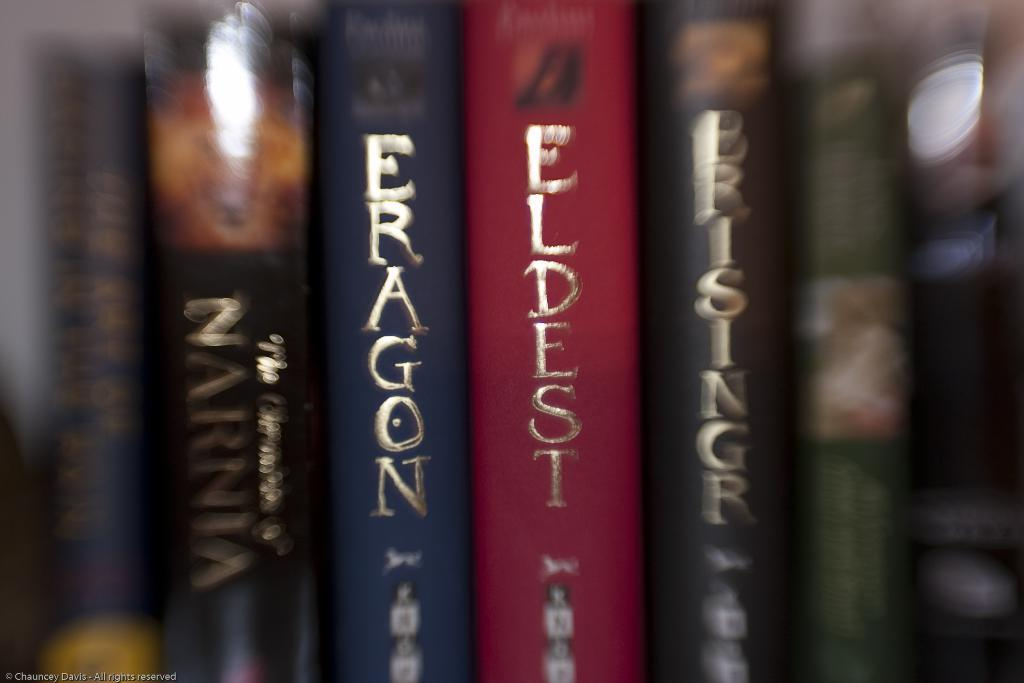Provide a one-sentence caption for the provided image. Books about eldest and eragon are lined up on a shelf. 